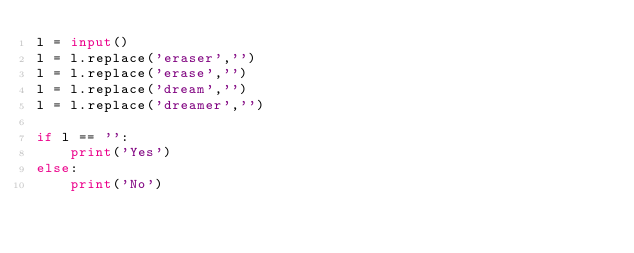Convert code to text. <code><loc_0><loc_0><loc_500><loc_500><_Python_>l = input()
l = l.replace('eraser','')
l = l.replace('erase','')
l = l.replace('dream','')
l = l.replace('dreamer','')

if l == '':
    print('Yes')
else:
    print('No')</code> 